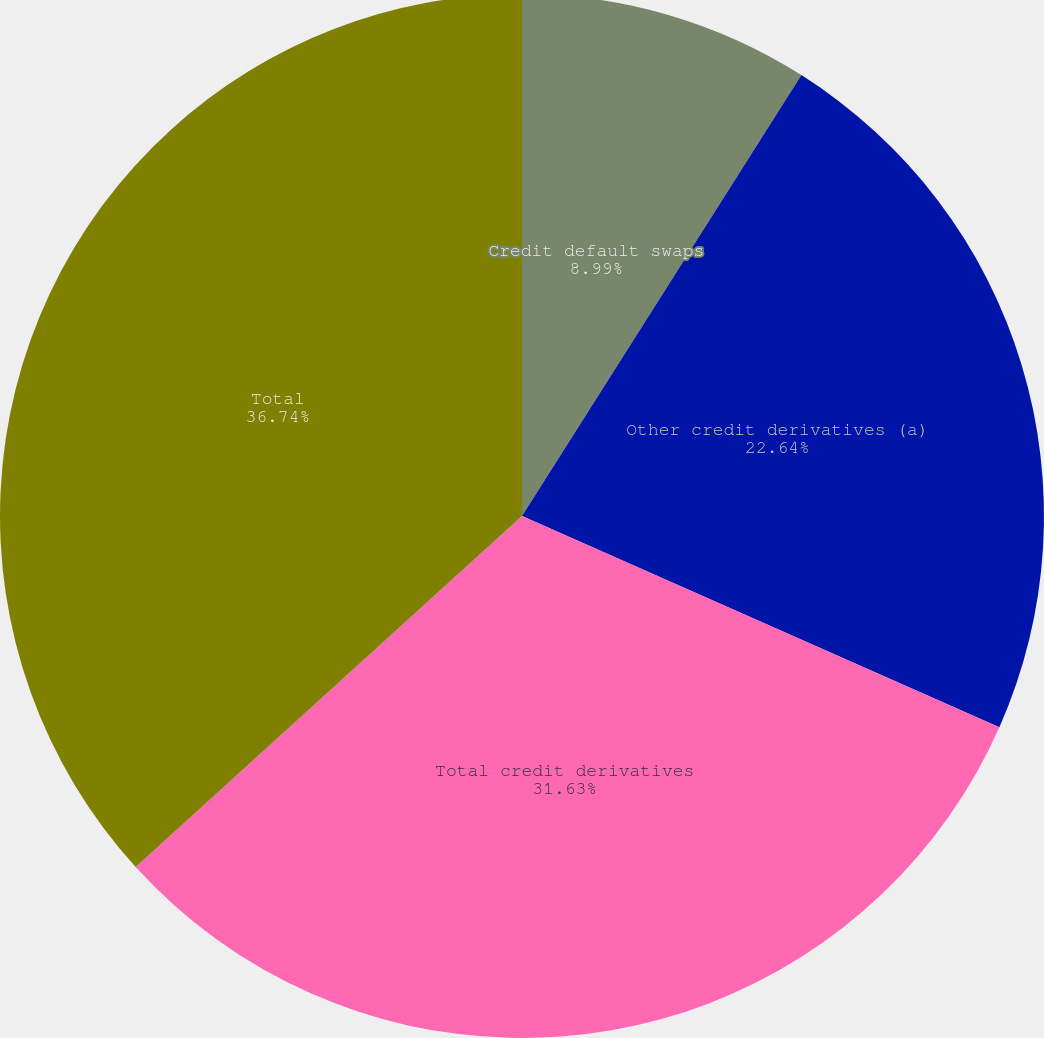Convert chart to OTSL. <chart><loc_0><loc_0><loc_500><loc_500><pie_chart><fcel>Credit default swaps<fcel>Other credit derivatives (a)<fcel>Total credit derivatives<fcel>Total<nl><fcel>8.99%<fcel>22.64%<fcel>31.63%<fcel>36.74%<nl></chart> 